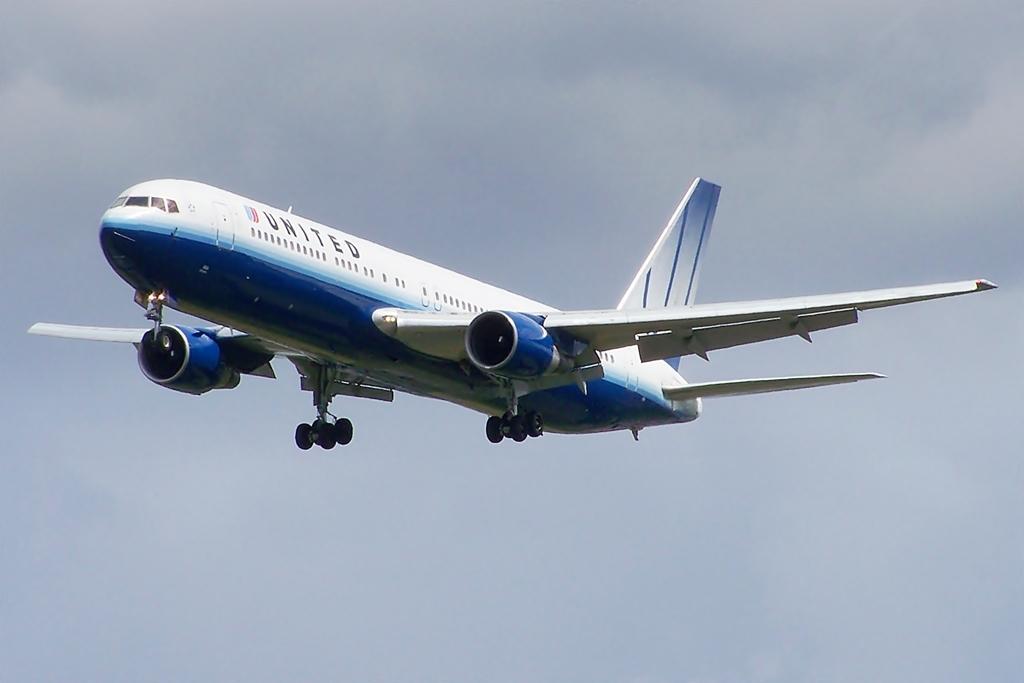How would you summarize this image in a sentence or two? In this picture we can see an airplane in the air. 